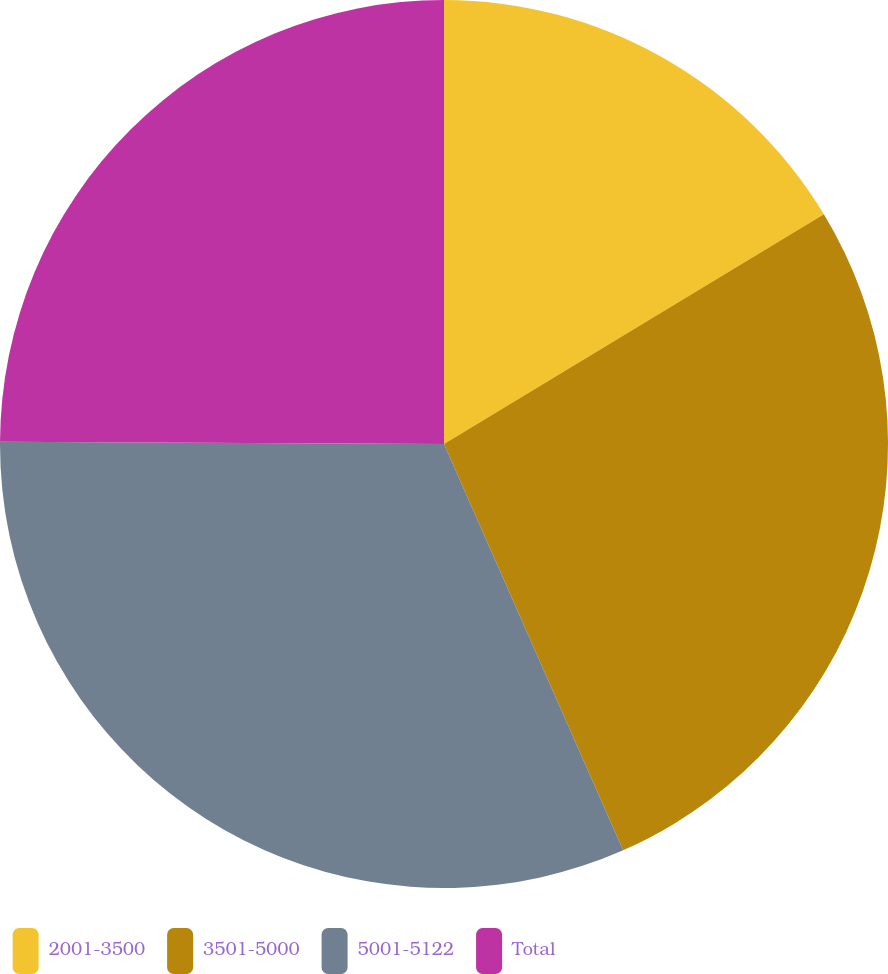Convert chart to OTSL. <chart><loc_0><loc_0><loc_500><loc_500><pie_chart><fcel>2001-3500<fcel>3501-5000<fcel>5001-5122<fcel>Total<nl><fcel>16.34%<fcel>27.05%<fcel>31.69%<fcel>24.92%<nl></chart> 